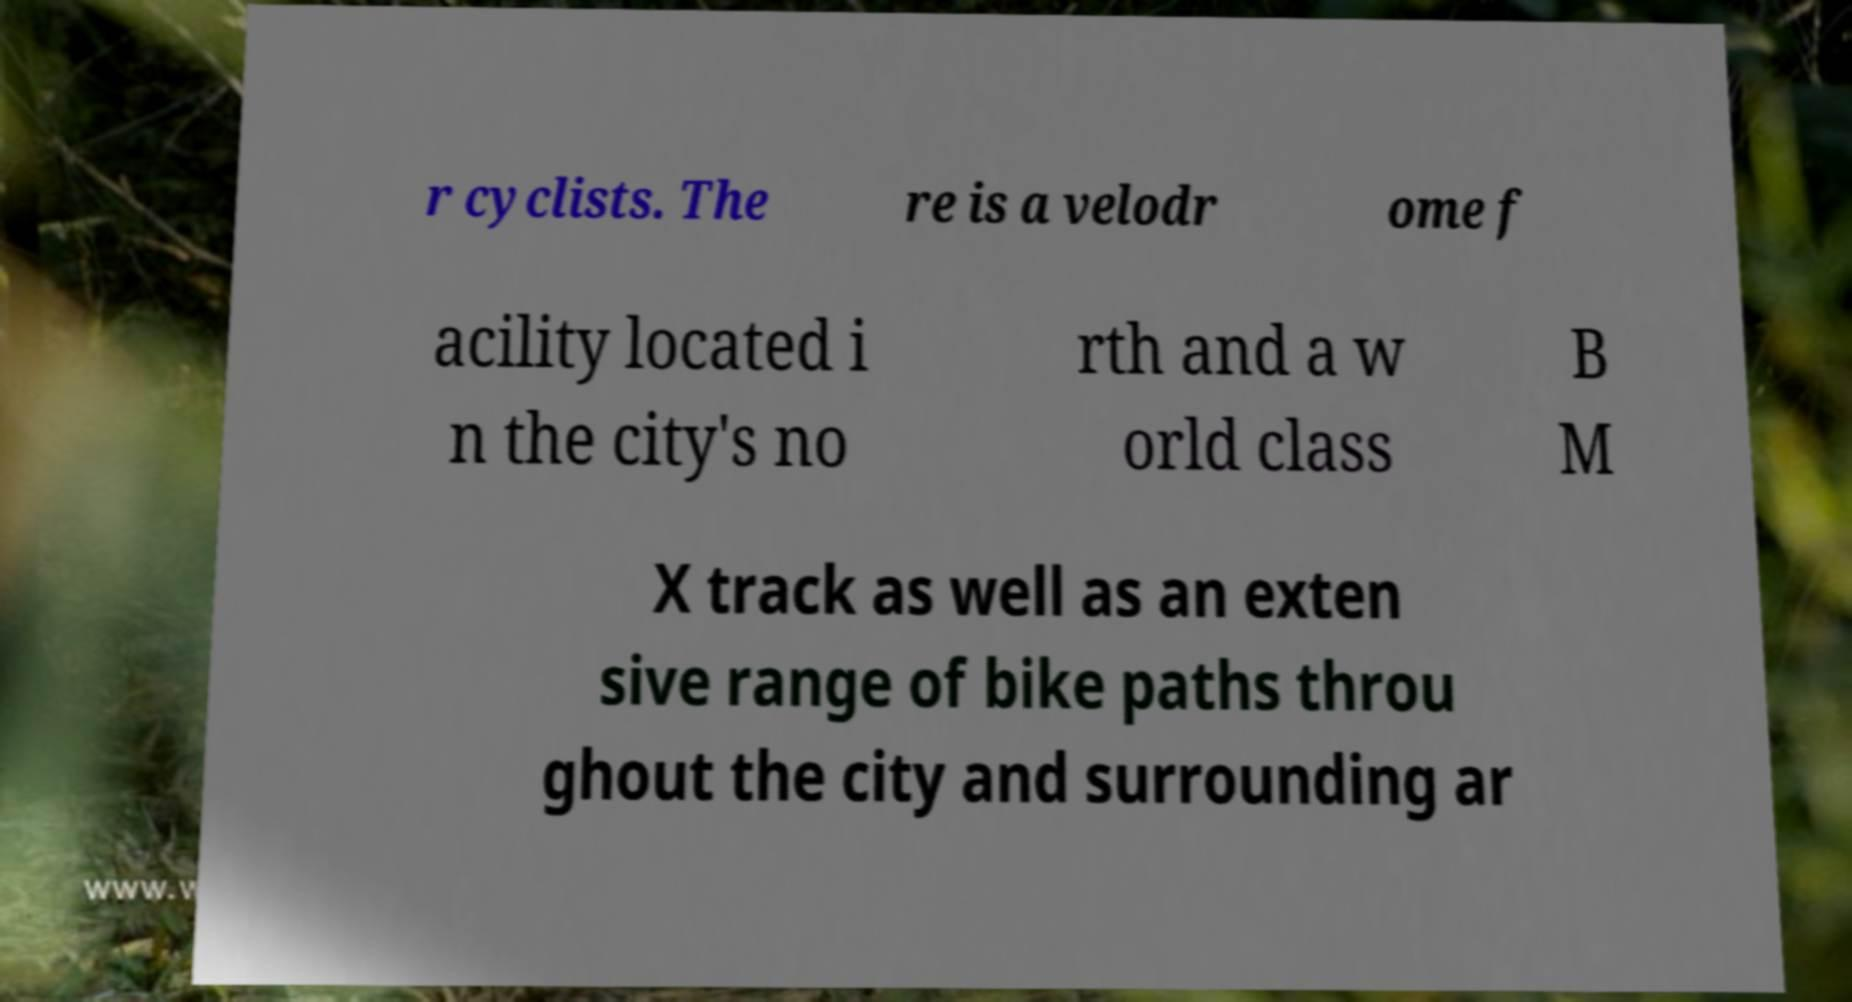Please read and relay the text visible in this image. What does it say? r cyclists. The re is a velodr ome f acility located i n the city's no rth and a w orld class B M X track as well as an exten sive range of bike paths throu ghout the city and surrounding ar 